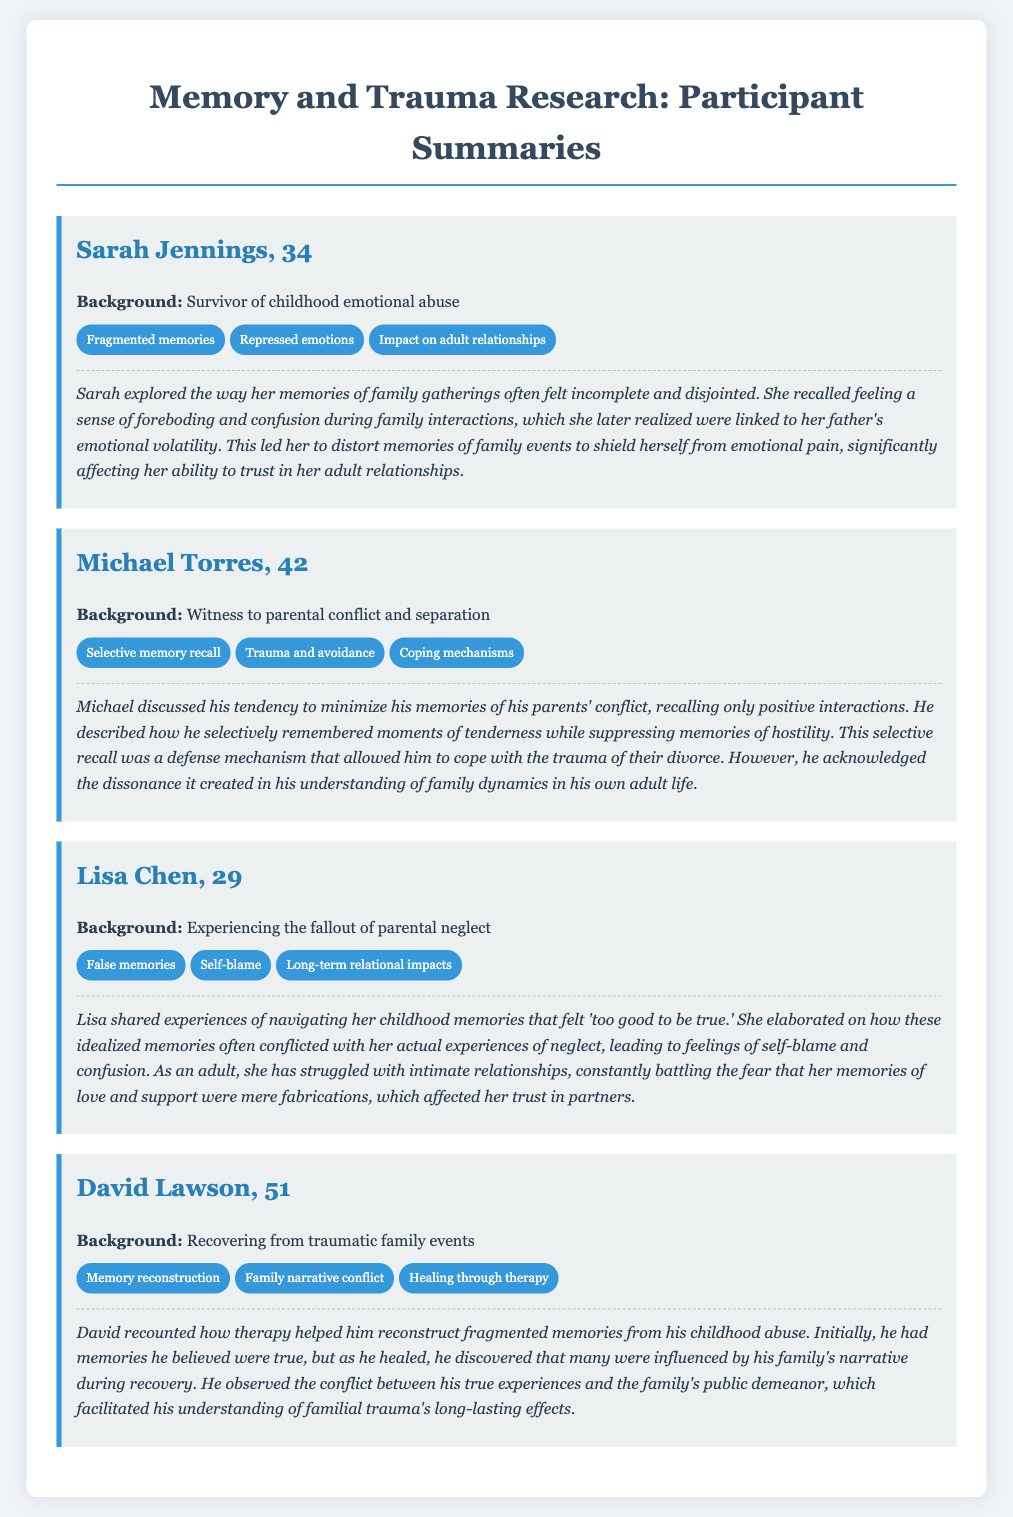What is Sarah Jennings' age? Sarah Jennings is identified as being 34 years old in the document.
Answer: 34 What type of abuse did Sarah experience? The document specifies that Sarah is a survivor of childhood emotional abuse.
Answer: Emotional abuse What is a key theme in Michael Torres' interview? The document highlights "Selective memory recall" as one of the key themes in Michael's interview.
Answer: Selective memory recall What coping mechanism does Michael mention? Michael describes his selective memory recall as a defense mechanism that helped him cope with trauma.
Answer: Defense mechanism How many participants are detailed in the document? The document contains detailed summaries of four participants.
Answer: Four What mental health intervention did David Lawson pursue? David mentions that therapy helped him reconstruct his fragmented memories.
Answer: Therapy Which participant's background involves parental neglect? Lisa Chen's background involves experiencing the fallout of parental neglect.
Answer: Lisa Chen What long-term relational impact does Lisa Chen discuss? Lisa mentions struggling with intimate relationships as a long-term impact of her experiences.
Answer: Struggling with intimate relationships What theme does David Lawson associate with memory reconstruction? David associates "Family narrative conflict" with memory reconstruction.
Answer: Family narrative conflict 